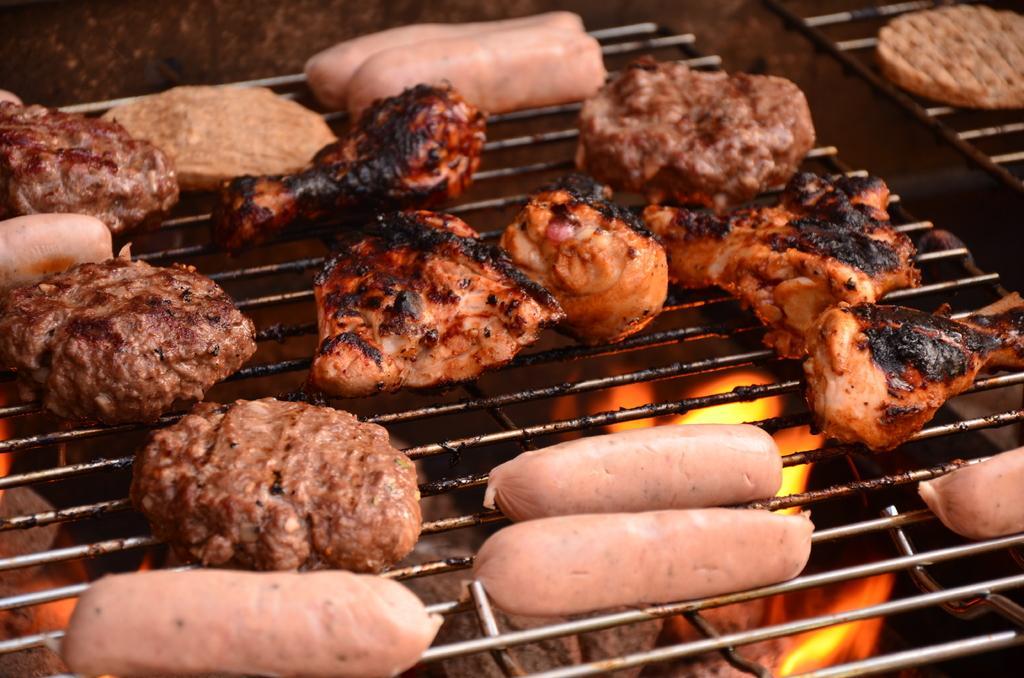Could you give a brief overview of what you see in this image? In this image we can see sausages and pieces of meat on the grill pan. We can also see fire under the grill pan. 